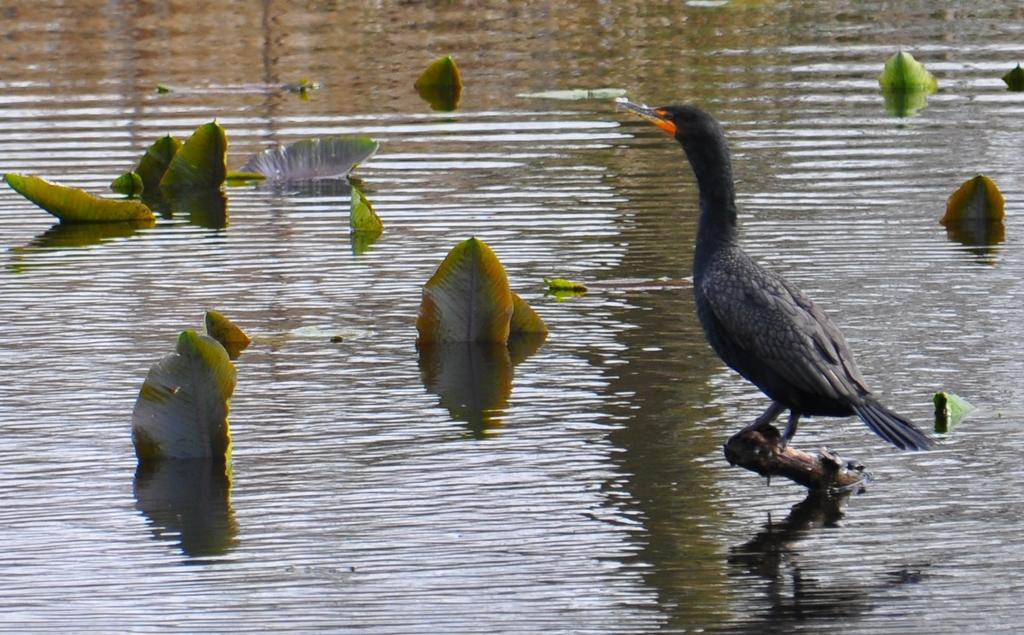What is the bird doing in the image? The bird is sitting on a stick in the image. Where is the bird located in the image? The bird is on the right side of the image. What can be seen in the background of the image? There is water visible in the image, and there are plants in the water. How many chairs are visible in the image? There are no chairs present in the image. What time of day is it in the image? The time is not visible or indicated in the image. 